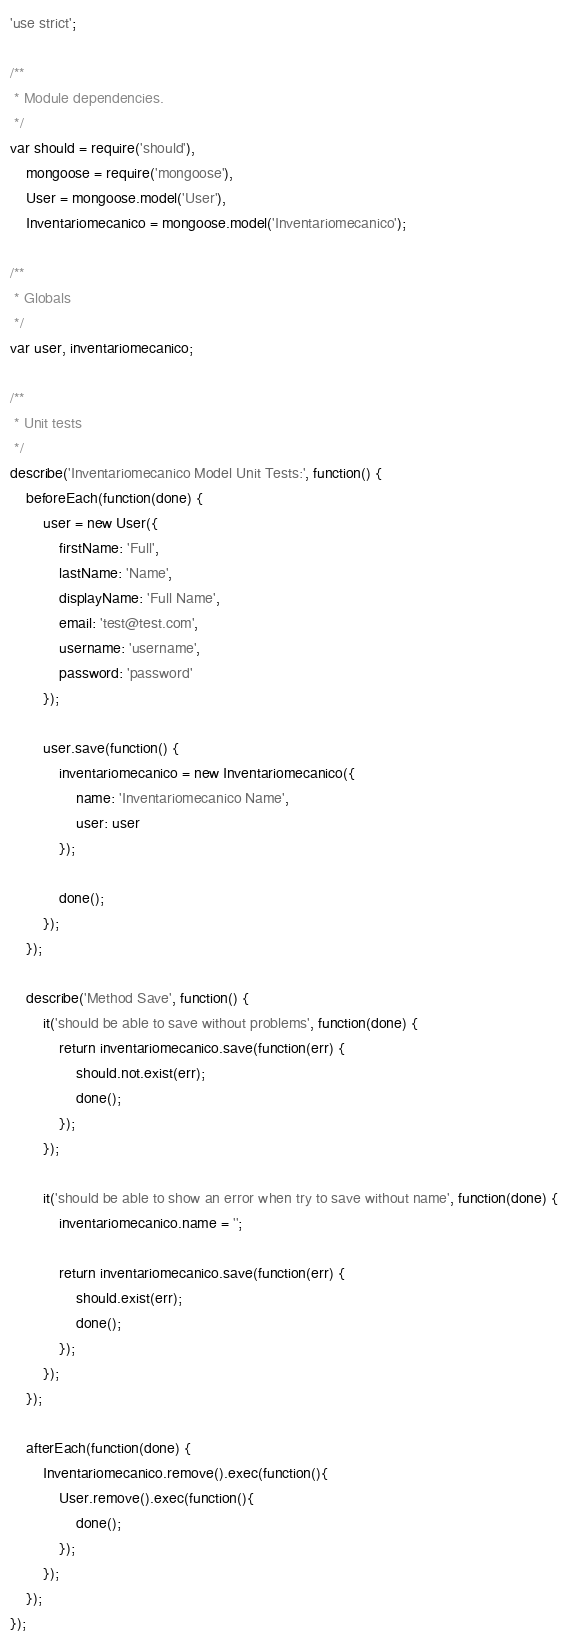Convert code to text. <code><loc_0><loc_0><loc_500><loc_500><_JavaScript_>'use strict';

/**
 * Module dependencies.
 */
var should = require('should'),
	mongoose = require('mongoose'),
	User = mongoose.model('User'),
	Inventariomecanico = mongoose.model('Inventariomecanico');

/**
 * Globals
 */
var user, inventariomecanico;

/**
 * Unit tests
 */
describe('Inventariomecanico Model Unit Tests:', function() {
	beforeEach(function(done) {
		user = new User({
			firstName: 'Full',
			lastName: 'Name',
			displayName: 'Full Name',
			email: 'test@test.com',
			username: 'username',
			password: 'password'
		});

		user.save(function() { 
			inventariomecanico = new Inventariomecanico({
				name: 'Inventariomecanico Name',
				user: user
			});

			done();
		});
	});

	describe('Method Save', function() {
		it('should be able to save without problems', function(done) {
			return inventariomecanico.save(function(err) {
				should.not.exist(err);
				done();
			});
		});

		it('should be able to show an error when try to save without name', function(done) { 
			inventariomecanico.name = '';

			return inventariomecanico.save(function(err) {
				should.exist(err);
				done();
			});
		});
	});

	afterEach(function(done) { 
		Inventariomecanico.remove().exec(function(){
			User.remove().exec(function(){
				done();	
			});
		});
	});
});
</code> 